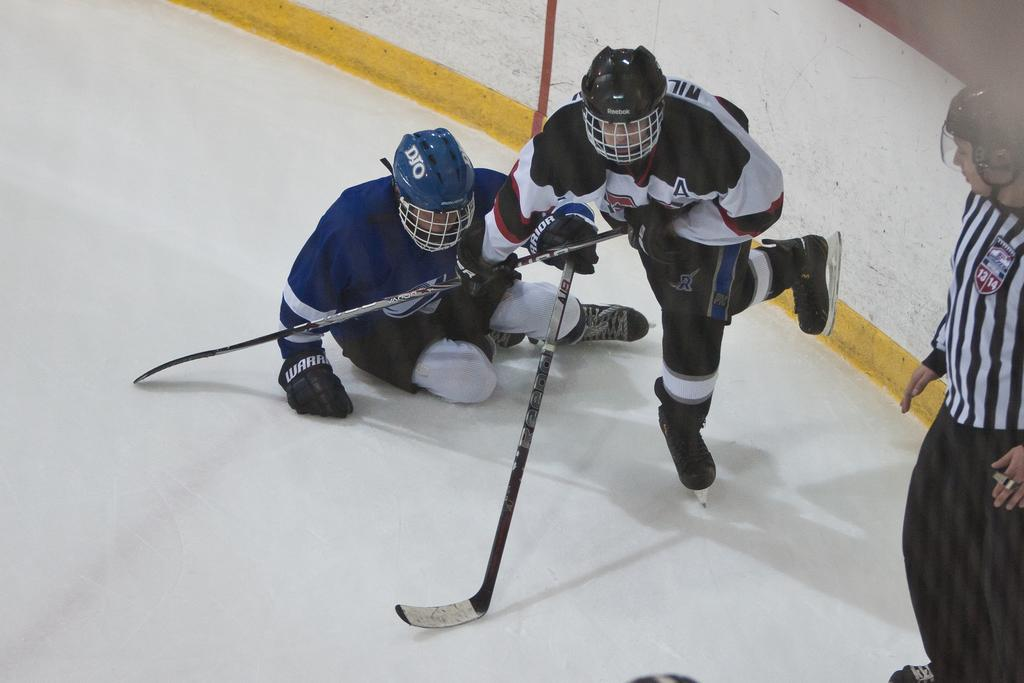What are the people in the image doing? There are persons playing in the center of the image. Can you describe the person on the right side in the front? There is a person standing on the right side in the front. What can be seen in the background of the image? There is a wall in the background of the image. What type of train can be seen passing by in the image? There is no train present in the image. What class of students are participating in the game in the image? There is no indication of a class or students in the image; it simply shows people playing. 